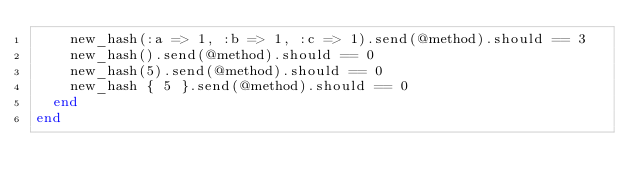Convert code to text. <code><loc_0><loc_0><loc_500><loc_500><_Ruby_>    new_hash(:a => 1, :b => 1, :c => 1).send(@method).should == 3
    new_hash().send(@method).should == 0
    new_hash(5).send(@method).should == 0
    new_hash { 5 }.send(@method).should == 0
  end
end
</code> 